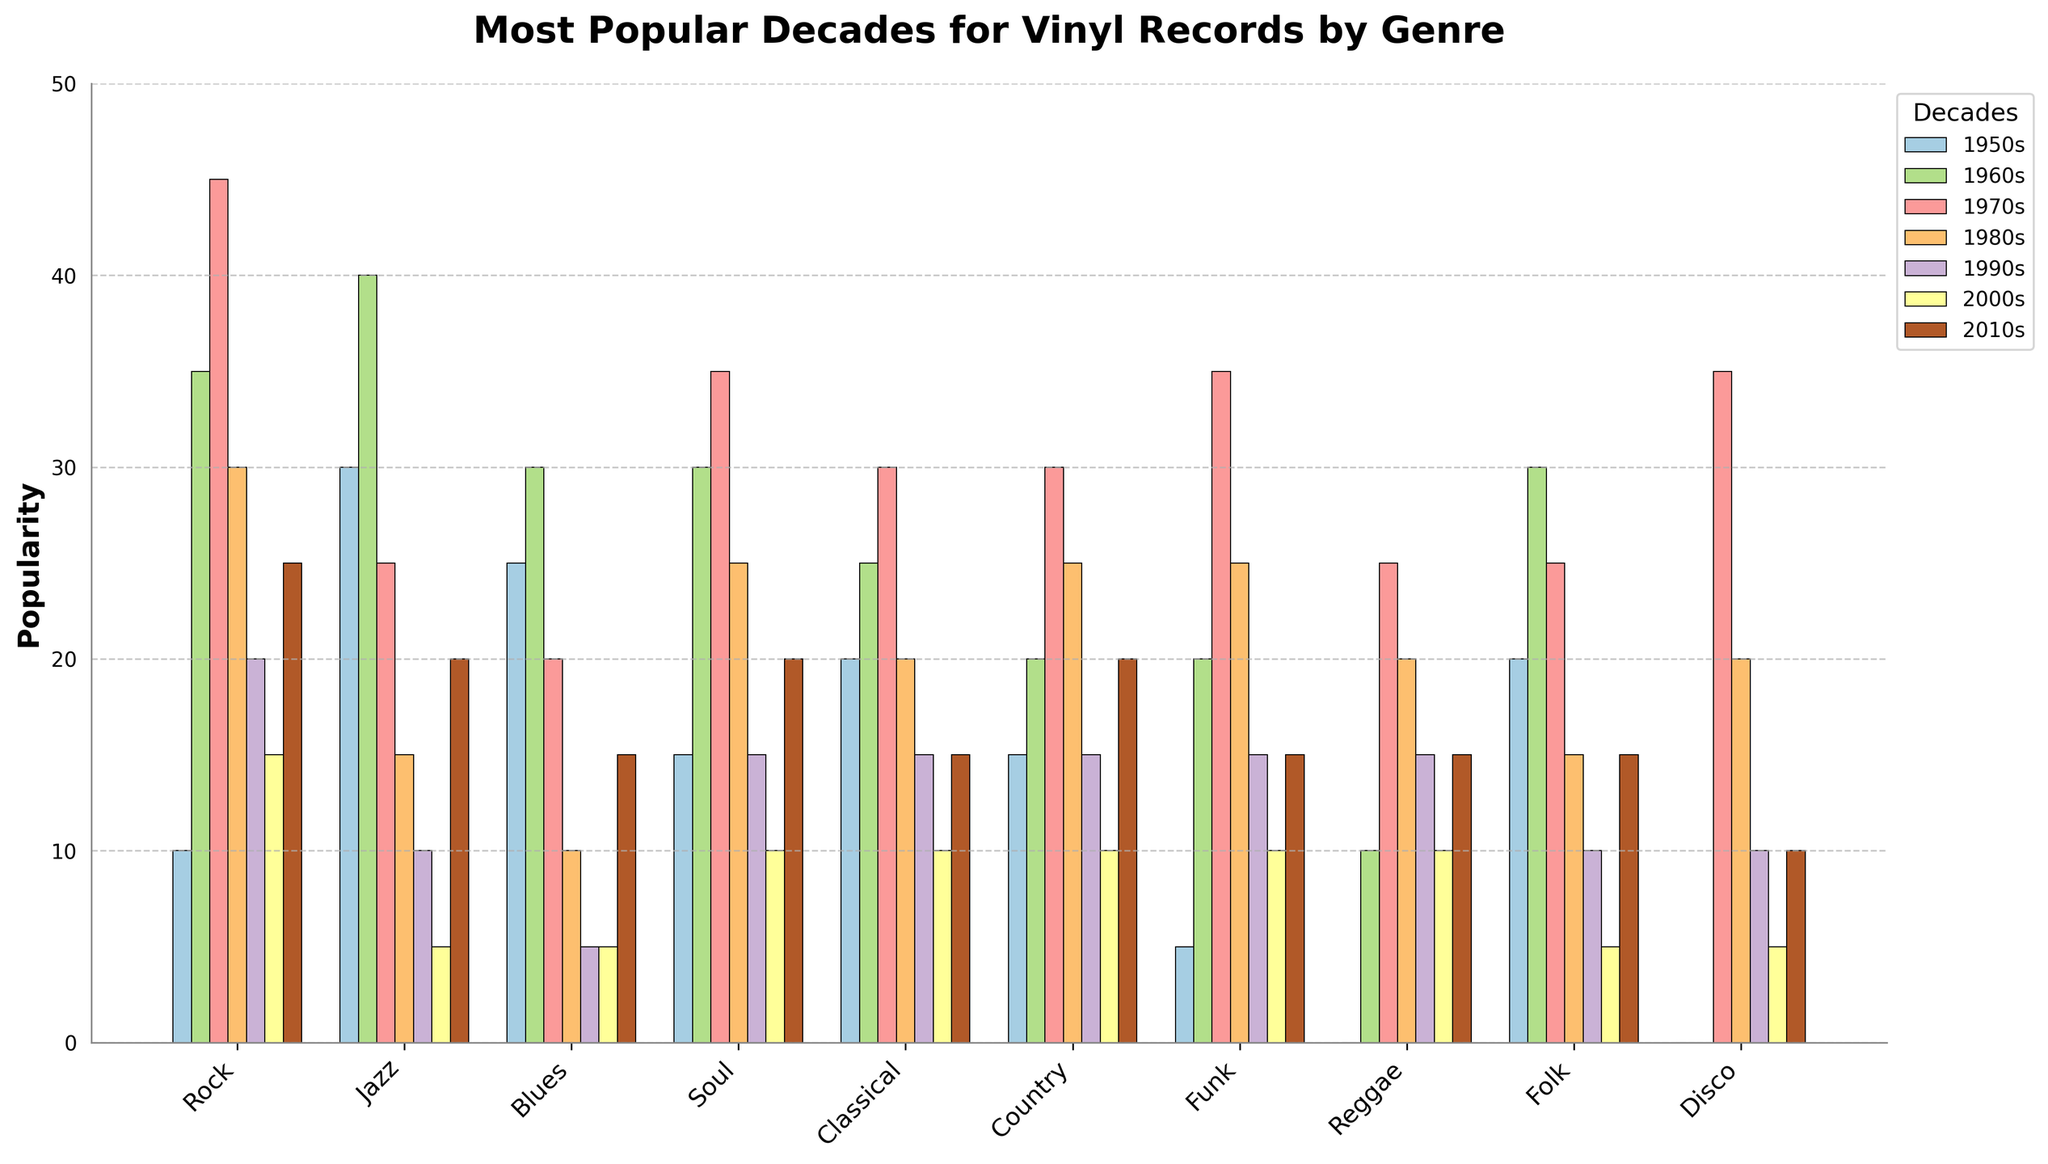Which genre had the highest popularity in the 1960s? Looking at the figure, identify the bar with the highest value in the 1960s category. The Jazz genre has the highest bar in that category.
Answer: Jazz Which decade showed the highest popularity for Rock music? Examine the heights of the bars for the Rock genre across all decades. The 1970s bar is the tallest for Rock.
Answer: 1970s How does the popularity of Disco in the 1970s compare to the 2000s? Compare the height of the Disco bar in the 1970s with the bar in the 2000s. The Disco bar in the 1970s is significantly taller.
Answer: Higher in the 1970s Sum the popularity of Classical music in the 1980s and the 1990s. Add the values of the bars for Classical in the 1980s and 1990s categories, which are 20 and 15, respectively. The total is 35.
Answer: 35 Which genre had the least increase in popularity from the 1980s to the 2010s? Calculate the difference in bar heights from the 1980s to the 2010s for each genre and identify the smallest change. Reggae changed from 20 to 15, resulting in a decrease of 5.
Answer: Reggae Which genre experienced the most consistent popularity across all decades? Evaluate the variance in the heights of the bars across all decades for each genre. Country appears to have the least variation in bar heights.
Answer: Country How does the popularity of Soul music in the 1970s compare to that in the 1990s? Compare the heights of the Soul bars in the 1970s and 1990s. The height of the Soul bar in the 1970s is greater than in the 1990s.
Answer: Higher in the 1970s Which decade had the second-highest popularity for Jazz music? Identify the decades and their respective bar heights for Jazz, excluding the highest (1960s with a height of 40). The next highest is the 1950s with 30.
Answer: 1950s In which decade did Blues music see the greatest drop in popularity from the previous decade? Calculate the difference in bar heights between consecutive decades for Blues. The greatest drop occurs from the 1960s to the 1970s (30 to 20).
Answer: 1970s Calculate the average popularity of Funk music across all decades. Sum up the popularity values for Funk across all decades (5 + 20 + 35 + 25 + 15 + 10 + 15 = 125) and divide by the number of decades (7). The average is 125/7 ≈ 17.86
Answer: 17.86 